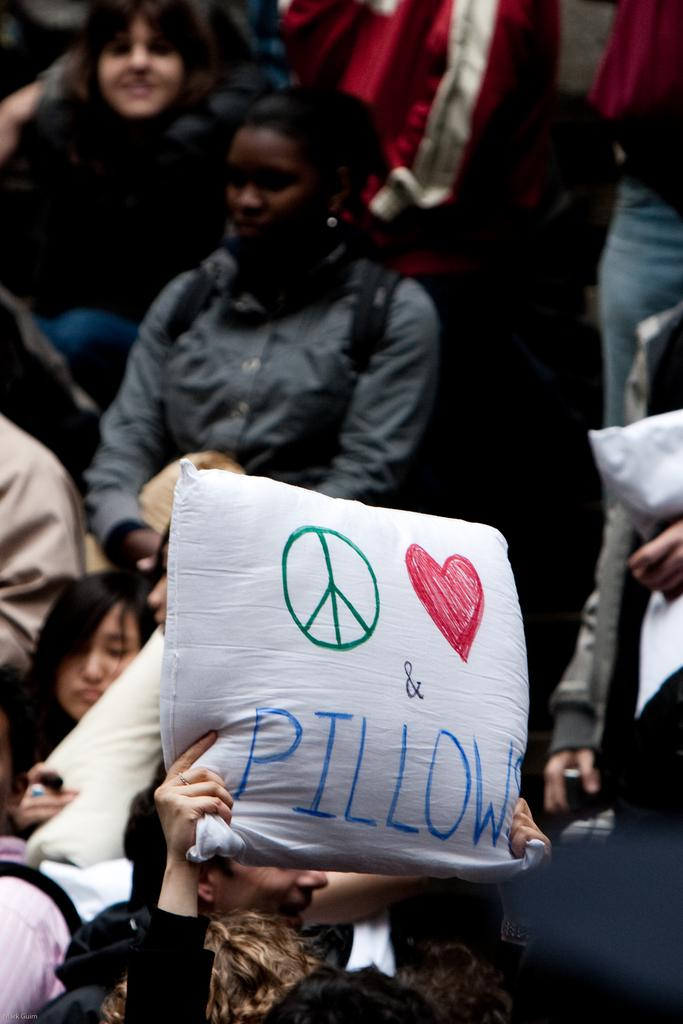What is the person in the image holding? The person in the image is holding a pillow. Can you describe the people visible behind the person holding the pillow? There are other people visible behind the person holding the pillow, but their specific actions or features are not mentioned in the facts. How many curves can be seen in the building behind the person holding the pillow? There is no building mentioned in the facts, so it is not possible to answer a question about curves in a building. 